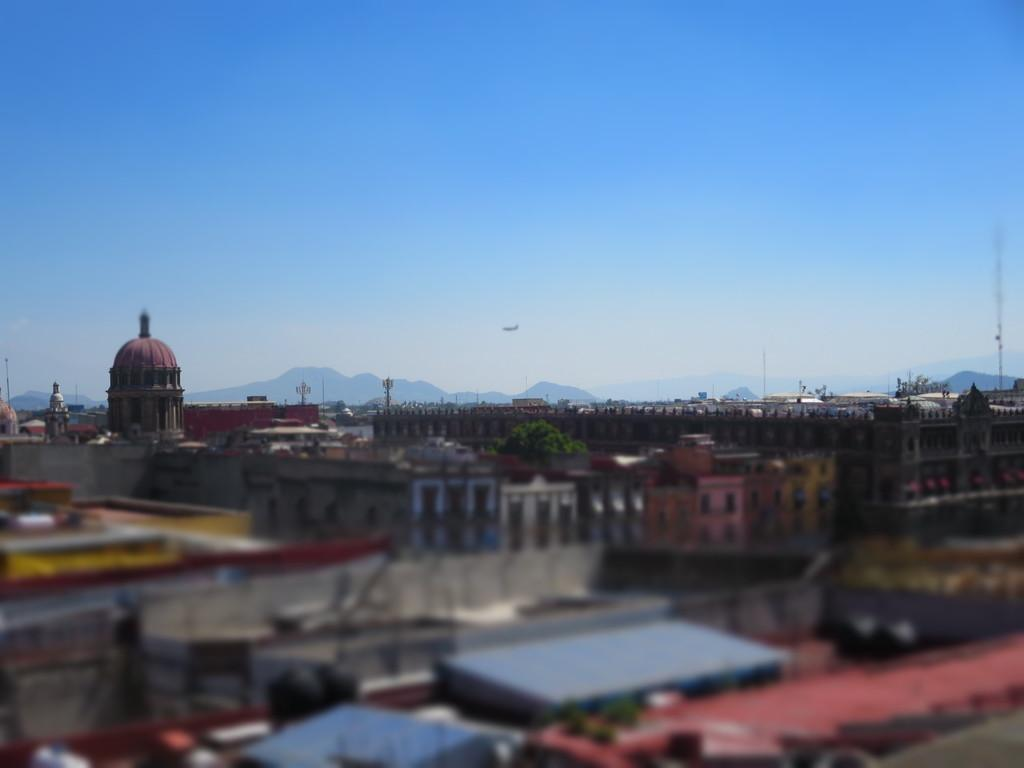What type of structures can be seen in the image? There are buildings in the image. What natural elements are present in the image? There are trees in the image. What man-made objects can be seen in the image? There are poles in the image. What can be seen in the distance in the image? There are mountains in the background of the image. What is visible in the sky in the image? The sky is visible in the background of the image. Can you see the face of the person who built the roof in the image? There is no person or roof present in the image; it features buildings, trees, poles, mountains, and the sky. 